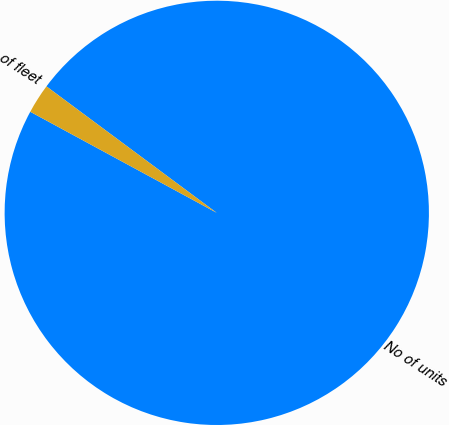<chart> <loc_0><loc_0><loc_500><loc_500><pie_chart><fcel>No of units<fcel>of fleet<nl><fcel>97.74%<fcel>2.26%<nl></chart> 